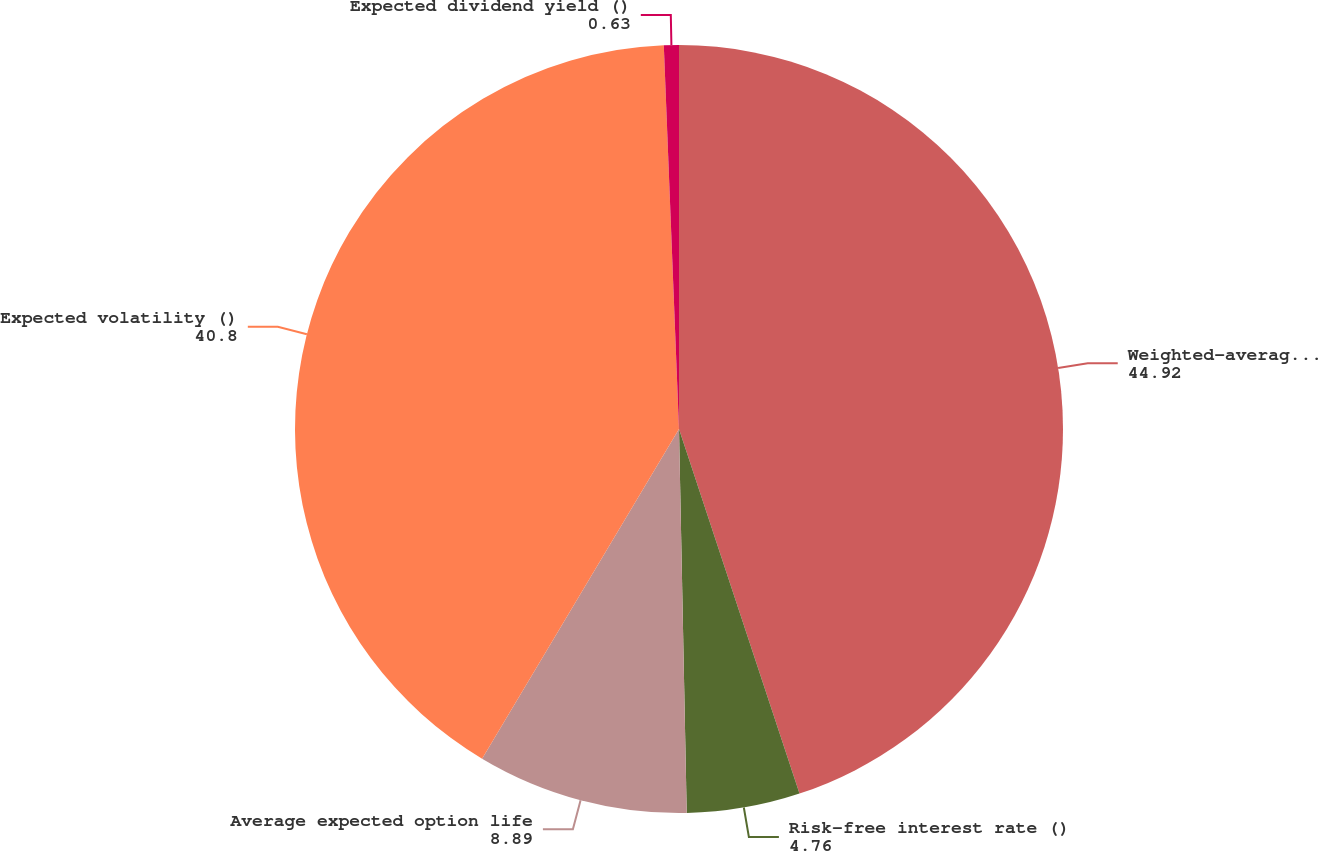<chart> <loc_0><loc_0><loc_500><loc_500><pie_chart><fcel>Weighted-average fair value ()<fcel>Risk-free interest rate ()<fcel>Average expected option life<fcel>Expected volatility ()<fcel>Expected dividend yield ()<nl><fcel>44.92%<fcel>4.76%<fcel>8.89%<fcel>40.8%<fcel>0.63%<nl></chart> 